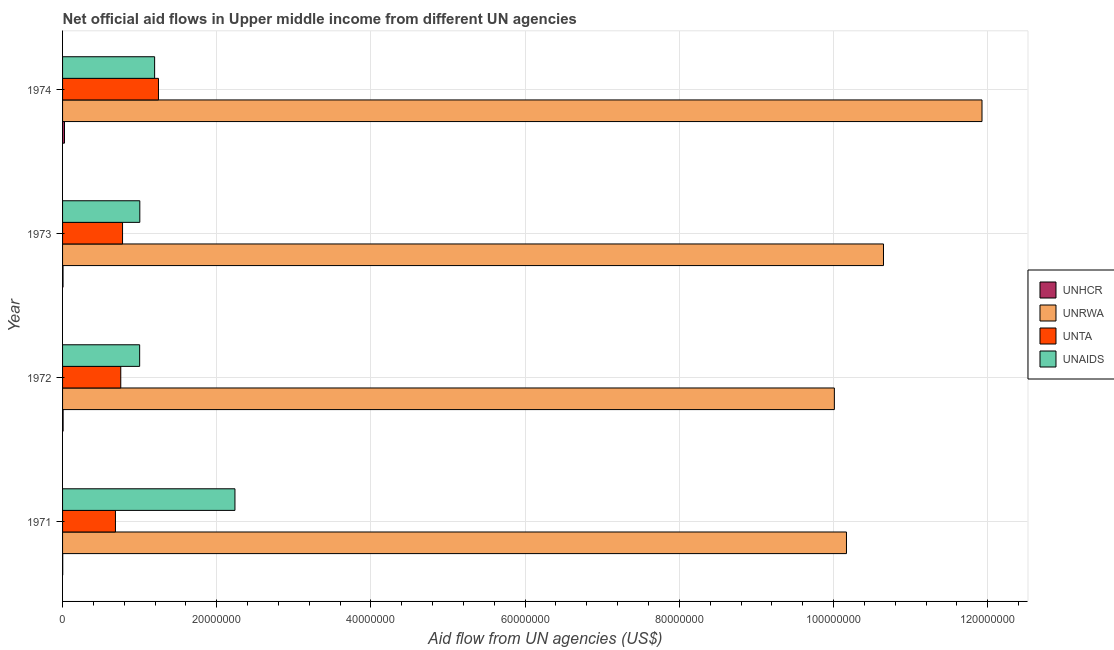How many different coloured bars are there?
Keep it short and to the point. 4. How many groups of bars are there?
Offer a terse response. 4. Are the number of bars per tick equal to the number of legend labels?
Provide a succinct answer. Yes. Are the number of bars on each tick of the Y-axis equal?
Your response must be concise. Yes. How many bars are there on the 4th tick from the bottom?
Offer a very short reply. 4. In how many cases, is the number of bars for a given year not equal to the number of legend labels?
Your response must be concise. 0. What is the amount of aid given by unhcr in 1973?
Offer a very short reply. 6.00e+04. Across all years, what is the maximum amount of aid given by unhcr?
Provide a succinct answer. 2.50e+05. Across all years, what is the minimum amount of aid given by unrwa?
Your answer should be compact. 1.00e+08. In which year was the amount of aid given by unaids maximum?
Provide a short and direct response. 1971. What is the total amount of aid given by unta in the graph?
Keep it short and to the point. 3.46e+07. What is the difference between the amount of aid given by unrwa in 1972 and that in 1974?
Keep it short and to the point. -1.92e+07. What is the difference between the amount of aid given by unhcr in 1972 and the amount of aid given by unaids in 1973?
Offer a very short reply. -9.95e+06. What is the average amount of aid given by unrwa per year?
Your response must be concise. 1.07e+08. In the year 1974, what is the difference between the amount of aid given by unrwa and amount of aid given by unaids?
Your answer should be very brief. 1.07e+08. In how many years, is the amount of aid given by unhcr greater than 116000000 US$?
Provide a succinct answer. 0. What is the ratio of the amount of aid given by unrwa in 1971 to that in 1972?
Offer a very short reply. 1.02. Is the amount of aid given by unaids in 1971 less than that in 1972?
Keep it short and to the point. No. What is the difference between the highest and the second highest amount of aid given by unta?
Keep it short and to the point. 4.66e+06. What is the difference between the highest and the lowest amount of aid given by unrwa?
Your response must be concise. 1.92e+07. Is the sum of the amount of aid given by unrwa in 1972 and 1973 greater than the maximum amount of aid given by unta across all years?
Your response must be concise. Yes. What does the 2nd bar from the top in 1972 represents?
Offer a very short reply. UNTA. What does the 3rd bar from the bottom in 1971 represents?
Keep it short and to the point. UNTA. Are the values on the major ticks of X-axis written in scientific E-notation?
Offer a terse response. No. Does the graph contain any zero values?
Provide a short and direct response. No. Where does the legend appear in the graph?
Make the answer very short. Center right. How are the legend labels stacked?
Your answer should be compact. Vertical. What is the title of the graph?
Provide a short and direct response. Net official aid flows in Upper middle income from different UN agencies. What is the label or title of the X-axis?
Your answer should be very brief. Aid flow from UN agencies (US$). What is the Aid flow from UN agencies (US$) of UNRWA in 1971?
Offer a very short reply. 1.02e+08. What is the Aid flow from UN agencies (US$) in UNTA in 1971?
Give a very brief answer. 6.86e+06. What is the Aid flow from UN agencies (US$) in UNAIDS in 1971?
Keep it short and to the point. 2.24e+07. What is the Aid flow from UN agencies (US$) in UNRWA in 1972?
Offer a very short reply. 1.00e+08. What is the Aid flow from UN agencies (US$) of UNTA in 1972?
Ensure brevity in your answer.  7.55e+06. What is the Aid flow from UN agencies (US$) in UNRWA in 1973?
Your answer should be very brief. 1.06e+08. What is the Aid flow from UN agencies (US$) of UNTA in 1973?
Give a very brief answer. 7.78e+06. What is the Aid flow from UN agencies (US$) in UNAIDS in 1973?
Ensure brevity in your answer.  1.00e+07. What is the Aid flow from UN agencies (US$) in UNRWA in 1974?
Offer a very short reply. 1.19e+08. What is the Aid flow from UN agencies (US$) in UNTA in 1974?
Offer a terse response. 1.24e+07. What is the Aid flow from UN agencies (US$) of UNAIDS in 1974?
Your answer should be very brief. 1.19e+07. Across all years, what is the maximum Aid flow from UN agencies (US$) in UNRWA?
Offer a terse response. 1.19e+08. Across all years, what is the maximum Aid flow from UN agencies (US$) in UNTA?
Ensure brevity in your answer.  1.24e+07. Across all years, what is the maximum Aid flow from UN agencies (US$) in UNAIDS?
Keep it short and to the point. 2.24e+07. Across all years, what is the minimum Aid flow from UN agencies (US$) in UNRWA?
Give a very brief answer. 1.00e+08. Across all years, what is the minimum Aid flow from UN agencies (US$) in UNTA?
Your answer should be compact. 6.86e+06. Across all years, what is the minimum Aid flow from UN agencies (US$) in UNAIDS?
Offer a very short reply. 1.00e+07. What is the total Aid flow from UN agencies (US$) of UNRWA in the graph?
Your answer should be compact. 4.28e+08. What is the total Aid flow from UN agencies (US$) in UNTA in the graph?
Your response must be concise. 3.46e+07. What is the total Aid flow from UN agencies (US$) in UNAIDS in the graph?
Your answer should be compact. 5.43e+07. What is the difference between the Aid flow from UN agencies (US$) in UNHCR in 1971 and that in 1972?
Offer a very short reply. -5.00e+04. What is the difference between the Aid flow from UN agencies (US$) in UNRWA in 1971 and that in 1972?
Keep it short and to the point. 1.57e+06. What is the difference between the Aid flow from UN agencies (US$) in UNTA in 1971 and that in 1972?
Offer a very short reply. -6.90e+05. What is the difference between the Aid flow from UN agencies (US$) of UNAIDS in 1971 and that in 1972?
Offer a terse response. 1.24e+07. What is the difference between the Aid flow from UN agencies (US$) in UNRWA in 1971 and that in 1973?
Offer a very short reply. -4.80e+06. What is the difference between the Aid flow from UN agencies (US$) in UNTA in 1971 and that in 1973?
Your answer should be very brief. -9.20e+05. What is the difference between the Aid flow from UN agencies (US$) of UNAIDS in 1971 and that in 1973?
Ensure brevity in your answer.  1.23e+07. What is the difference between the Aid flow from UN agencies (US$) in UNRWA in 1971 and that in 1974?
Offer a very short reply. -1.76e+07. What is the difference between the Aid flow from UN agencies (US$) of UNTA in 1971 and that in 1974?
Your response must be concise. -5.58e+06. What is the difference between the Aid flow from UN agencies (US$) in UNAIDS in 1971 and that in 1974?
Provide a succinct answer. 1.04e+07. What is the difference between the Aid flow from UN agencies (US$) in UNRWA in 1972 and that in 1973?
Your answer should be very brief. -6.37e+06. What is the difference between the Aid flow from UN agencies (US$) in UNAIDS in 1972 and that in 1973?
Your response must be concise. -2.00e+04. What is the difference between the Aid flow from UN agencies (US$) in UNHCR in 1972 and that in 1974?
Provide a short and direct response. -1.80e+05. What is the difference between the Aid flow from UN agencies (US$) of UNRWA in 1972 and that in 1974?
Give a very brief answer. -1.92e+07. What is the difference between the Aid flow from UN agencies (US$) in UNTA in 1972 and that in 1974?
Your answer should be very brief. -4.89e+06. What is the difference between the Aid flow from UN agencies (US$) of UNAIDS in 1972 and that in 1974?
Offer a very short reply. -1.94e+06. What is the difference between the Aid flow from UN agencies (US$) of UNRWA in 1973 and that in 1974?
Offer a very short reply. -1.28e+07. What is the difference between the Aid flow from UN agencies (US$) in UNTA in 1973 and that in 1974?
Give a very brief answer. -4.66e+06. What is the difference between the Aid flow from UN agencies (US$) of UNAIDS in 1973 and that in 1974?
Keep it short and to the point. -1.92e+06. What is the difference between the Aid flow from UN agencies (US$) in UNHCR in 1971 and the Aid flow from UN agencies (US$) in UNRWA in 1972?
Give a very brief answer. -1.00e+08. What is the difference between the Aid flow from UN agencies (US$) of UNHCR in 1971 and the Aid flow from UN agencies (US$) of UNTA in 1972?
Keep it short and to the point. -7.53e+06. What is the difference between the Aid flow from UN agencies (US$) in UNHCR in 1971 and the Aid flow from UN agencies (US$) in UNAIDS in 1972?
Make the answer very short. -9.98e+06. What is the difference between the Aid flow from UN agencies (US$) in UNRWA in 1971 and the Aid flow from UN agencies (US$) in UNTA in 1972?
Make the answer very short. 9.41e+07. What is the difference between the Aid flow from UN agencies (US$) in UNRWA in 1971 and the Aid flow from UN agencies (US$) in UNAIDS in 1972?
Offer a terse response. 9.17e+07. What is the difference between the Aid flow from UN agencies (US$) of UNTA in 1971 and the Aid flow from UN agencies (US$) of UNAIDS in 1972?
Offer a terse response. -3.14e+06. What is the difference between the Aid flow from UN agencies (US$) of UNHCR in 1971 and the Aid flow from UN agencies (US$) of UNRWA in 1973?
Offer a terse response. -1.06e+08. What is the difference between the Aid flow from UN agencies (US$) in UNHCR in 1971 and the Aid flow from UN agencies (US$) in UNTA in 1973?
Your answer should be very brief. -7.76e+06. What is the difference between the Aid flow from UN agencies (US$) in UNHCR in 1971 and the Aid flow from UN agencies (US$) in UNAIDS in 1973?
Your answer should be compact. -1.00e+07. What is the difference between the Aid flow from UN agencies (US$) in UNRWA in 1971 and the Aid flow from UN agencies (US$) in UNTA in 1973?
Your answer should be very brief. 9.39e+07. What is the difference between the Aid flow from UN agencies (US$) of UNRWA in 1971 and the Aid flow from UN agencies (US$) of UNAIDS in 1973?
Provide a short and direct response. 9.17e+07. What is the difference between the Aid flow from UN agencies (US$) in UNTA in 1971 and the Aid flow from UN agencies (US$) in UNAIDS in 1973?
Your response must be concise. -3.16e+06. What is the difference between the Aid flow from UN agencies (US$) of UNHCR in 1971 and the Aid flow from UN agencies (US$) of UNRWA in 1974?
Your answer should be very brief. -1.19e+08. What is the difference between the Aid flow from UN agencies (US$) of UNHCR in 1971 and the Aid flow from UN agencies (US$) of UNTA in 1974?
Your answer should be very brief. -1.24e+07. What is the difference between the Aid flow from UN agencies (US$) of UNHCR in 1971 and the Aid flow from UN agencies (US$) of UNAIDS in 1974?
Provide a short and direct response. -1.19e+07. What is the difference between the Aid flow from UN agencies (US$) in UNRWA in 1971 and the Aid flow from UN agencies (US$) in UNTA in 1974?
Provide a succinct answer. 8.92e+07. What is the difference between the Aid flow from UN agencies (US$) in UNRWA in 1971 and the Aid flow from UN agencies (US$) in UNAIDS in 1974?
Your answer should be very brief. 8.97e+07. What is the difference between the Aid flow from UN agencies (US$) in UNTA in 1971 and the Aid flow from UN agencies (US$) in UNAIDS in 1974?
Offer a very short reply. -5.08e+06. What is the difference between the Aid flow from UN agencies (US$) in UNHCR in 1972 and the Aid flow from UN agencies (US$) in UNRWA in 1973?
Provide a succinct answer. -1.06e+08. What is the difference between the Aid flow from UN agencies (US$) in UNHCR in 1972 and the Aid flow from UN agencies (US$) in UNTA in 1973?
Offer a terse response. -7.71e+06. What is the difference between the Aid flow from UN agencies (US$) of UNHCR in 1972 and the Aid flow from UN agencies (US$) of UNAIDS in 1973?
Offer a very short reply. -9.95e+06. What is the difference between the Aid flow from UN agencies (US$) of UNRWA in 1972 and the Aid flow from UN agencies (US$) of UNTA in 1973?
Provide a short and direct response. 9.23e+07. What is the difference between the Aid flow from UN agencies (US$) in UNRWA in 1972 and the Aid flow from UN agencies (US$) in UNAIDS in 1973?
Give a very brief answer. 9.01e+07. What is the difference between the Aid flow from UN agencies (US$) in UNTA in 1972 and the Aid flow from UN agencies (US$) in UNAIDS in 1973?
Offer a very short reply. -2.47e+06. What is the difference between the Aid flow from UN agencies (US$) in UNHCR in 1972 and the Aid flow from UN agencies (US$) in UNRWA in 1974?
Your answer should be compact. -1.19e+08. What is the difference between the Aid flow from UN agencies (US$) of UNHCR in 1972 and the Aid flow from UN agencies (US$) of UNTA in 1974?
Provide a short and direct response. -1.24e+07. What is the difference between the Aid flow from UN agencies (US$) of UNHCR in 1972 and the Aid flow from UN agencies (US$) of UNAIDS in 1974?
Your response must be concise. -1.19e+07. What is the difference between the Aid flow from UN agencies (US$) of UNRWA in 1972 and the Aid flow from UN agencies (US$) of UNTA in 1974?
Your answer should be compact. 8.77e+07. What is the difference between the Aid flow from UN agencies (US$) in UNRWA in 1972 and the Aid flow from UN agencies (US$) in UNAIDS in 1974?
Keep it short and to the point. 8.82e+07. What is the difference between the Aid flow from UN agencies (US$) in UNTA in 1972 and the Aid flow from UN agencies (US$) in UNAIDS in 1974?
Give a very brief answer. -4.39e+06. What is the difference between the Aid flow from UN agencies (US$) in UNHCR in 1973 and the Aid flow from UN agencies (US$) in UNRWA in 1974?
Offer a terse response. -1.19e+08. What is the difference between the Aid flow from UN agencies (US$) in UNHCR in 1973 and the Aid flow from UN agencies (US$) in UNTA in 1974?
Provide a short and direct response. -1.24e+07. What is the difference between the Aid flow from UN agencies (US$) of UNHCR in 1973 and the Aid flow from UN agencies (US$) of UNAIDS in 1974?
Offer a terse response. -1.19e+07. What is the difference between the Aid flow from UN agencies (US$) in UNRWA in 1973 and the Aid flow from UN agencies (US$) in UNTA in 1974?
Your answer should be very brief. 9.40e+07. What is the difference between the Aid flow from UN agencies (US$) in UNRWA in 1973 and the Aid flow from UN agencies (US$) in UNAIDS in 1974?
Your answer should be very brief. 9.45e+07. What is the difference between the Aid flow from UN agencies (US$) of UNTA in 1973 and the Aid flow from UN agencies (US$) of UNAIDS in 1974?
Provide a short and direct response. -4.16e+06. What is the average Aid flow from UN agencies (US$) in UNRWA per year?
Make the answer very short. 1.07e+08. What is the average Aid flow from UN agencies (US$) in UNTA per year?
Give a very brief answer. 8.66e+06. What is the average Aid flow from UN agencies (US$) of UNAIDS per year?
Offer a very short reply. 1.36e+07. In the year 1971, what is the difference between the Aid flow from UN agencies (US$) in UNHCR and Aid flow from UN agencies (US$) in UNRWA?
Ensure brevity in your answer.  -1.02e+08. In the year 1971, what is the difference between the Aid flow from UN agencies (US$) of UNHCR and Aid flow from UN agencies (US$) of UNTA?
Ensure brevity in your answer.  -6.84e+06. In the year 1971, what is the difference between the Aid flow from UN agencies (US$) of UNHCR and Aid flow from UN agencies (US$) of UNAIDS?
Give a very brief answer. -2.23e+07. In the year 1971, what is the difference between the Aid flow from UN agencies (US$) of UNRWA and Aid flow from UN agencies (US$) of UNTA?
Provide a short and direct response. 9.48e+07. In the year 1971, what is the difference between the Aid flow from UN agencies (US$) of UNRWA and Aid flow from UN agencies (US$) of UNAIDS?
Provide a short and direct response. 7.93e+07. In the year 1971, what is the difference between the Aid flow from UN agencies (US$) of UNTA and Aid flow from UN agencies (US$) of UNAIDS?
Ensure brevity in your answer.  -1.55e+07. In the year 1972, what is the difference between the Aid flow from UN agencies (US$) in UNHCR and Aid flow from UN agencies (US$) in UNRWA?
Offer a terse response. -1.00e+08. In the year 1972, what is the difference between the Aid flow from UN agencies (US$) in UNHCR and Aid flow from UN agencies (US$) in UNTA?
Ensure brevity in your answer.  -7.48e+06. In the year 1972, what is the difference between the Aid flow from UN agencies (US$) in UNHCR and Aid flow from UN agencies (US$) in UNAIDS?
Your answer should be very brief. -9.93e+06. In the year 1972, what is the difference between the Aid flow from UN agencies (US$) in UNRWA and Aid flow from UN agencies (US$) in UNTA?
Offer a terse response. 9.26e+07. In the year 1972, what is the difference between the Aid flow from UN agencies (US$) of UNRWA and Aid flow from UN agencies (US$) of UNAIDS?
Ensure brevity in your answer.  9.01e+07. In the year 1972, what is the difference between the Aid flow from UN agencies (US$) of UNTA and Aid flow from UN agencies (US$) of UNAIDS?
Offer a terse response. -2.45e+06. In the year 1973, what is the difference between the Aid flow from UN agencies (US$) of UNHCR and Aid flow from UN agencies (US$) of UNRWA?
Provide a succinct answer. -1.06e+08. In the year 1973, what is the difference between the Aid flow from UN agencies (US$) of UNHCR and Aid flow from UN agencies (US$) of UNTA?
Offer a very short reply. -7.72e+06. In the year 1973, what is the difference between the Aid flow from UN agencies (US$) of UNHCR and Aid flow from UN agencies (US$) of UNAIDS?
Your answer should be compact. -9.96e+06. In the year 1973, what is the difference between the Aid flow from UN agencies (US$) in UNRWA and Aid flow from UN agencies (US$) in UNTA?
Keep it short and to the point. 9.87e+07. In the year 1973, what is the difference between the Aid flow from UN agencies (US$) in UNRWA and Aid flow from UN agencies (US$) in UNAIDS?
Offer a terse response. 9.65e+07. In the year 1973, what is the difference between the Aid flow from UN agencies (US$) in UNTA and Aid flow from UN agencies (US$) in UNAIDS?
Ensure brevity in your answer.  -2.24e+06. In the year 1974, what is the difference between the Aid flow from UN agencies (US$) of UNHCR and Aid flow from UN agencies (US$) of UNRWA?
Ensure brevity in your answer.  -1.19e+08. In the year 1974, what is the difference between the Aid flow from UN agencies (US$) in UNHCR and Aid flow from UN agencies (US$) in UNTA?
Ensure brevity in your answer.  -1.22e+07. In the year 1974, what is the difference between the Aid flow from UN agencies (US$) in UNHCR and Aid flow from UN agencies (US$) in UNAIDS?
Your answer should be compact. -1.17e+07. In the year 1974, what is the difference between the Aid flow from UN agencies (US$) in UNRWA and Aid flow from UN agencies (US$) in UNTA?
Provide a short and direct response. 1.07e+08. In the year 1974, what is the difference between the Aid flow from UN agencies (US$) in UNRWA and Aid flow from UN agencies (US$) in UNAIDS?
Offer a very short reply. 1.07e+08. What is the ratio of the Aid flow from UN agencies (US$) of UNHCR in 1971 to that in 1972?
Give a very brief answer. 0.29. What is the ratio of the Aid flow from UN agencies (US$) in UNRWA in 1971 to that in 1972?
Your response must be concise. 1.02. What is the ratio of the Aid flow from UN agencies (US$) in UNTA in 1971 to that in 1972?
Offer a very short reply. 0.91. What is the ratio of the Aid flow from UN agencies (US$) of UNAIDS in 1971 to that in 1972?
Offer a very short reply. 2.24. What is the ratio of the Aid flow from UN agencies (US$) in UNHCR in 1971 to that in 1973?
Make the answer very short. 0.33. What is the ratio of the Aid flow from UN agencies (US$) in UNRWA in 1971 to that in 1973?
Ensure brevity in your answer.  0.95. What is the ratio of the Aid flow from UN agencies (US$) of UNTA in 1971 to that in 1973?
Provide a short and direct response. 0.88. What is the ratio of the Aid flow from UN agencies (US$) of UNAIDS in 1971 to that in 1973?
Your answer should be very brief. 2.23. What is the ratio of the Aid flow from UN agencies (US$) in UNRWA in 1971 to that in 1974?
Your answer should be compact. 0.85. What is the ratio of the Aid flow from UN agencies (US$) of UNTA in 1971 to that in 1974?
Offer a very short reply. 0.55. What is the ratio of the Aid flow from UN agencies (US$) of UNAIDS in 1971 to that in 1974?
Your answer should be compact. 1.87. What is the ratio of the Aid flow from UN agencies (US$) of UNRWA in 1972 to that in 1973?
Ensure brevity in your answer.  0.94. What is the ratio of the Aid flow from UN agencies (US$) in UNTA in 1972 to that in 1973?
Give a very brief answer. 0.97. What is the ratio of the Aid flow from UN agencies (US$) of UNHCR in 1972 to that in 1974?
Offer a terse response. 0.28. What is the ratio of the Aid flow from UN agencies (US$) in UNRWA in 1972 to that in 1974?
Provide a short and direct response. 0.84. What is the ratio of the Aid flow from UN agencies (US$) of UNTA in 1972 to that in 1974?
Your answer should be compact. 0.61. What is the ratio of the Aid flow from UN agencies (US$) in UNAIDS in 1972 to that in 1974?
Give a very brief answer. 0.84. What is the ratio of the Aid flow from UN agencies (US$) in UNHCR in 1973 to that in 1974?
Give a very brief answer. 0.24. What is the ratio of the Aid flow from UN agencies (US$) in UNRWA in 1973 to that in 1974?
Your answer should be very brief. 0.89. What is the ratio of the Aid flow from UN agencies (US$) of UNTA in 1973 to that in 1974?
Offer a very short reply. 0.63. What is the ratio of the Aid flow from UN agencies (US$) of UNAIDS in 1973 to that in 1974?
Provide a succinct answer. 0.84. What is the difference between the highest and the second highest Aid flow from UN agencies (US$) of UNHCR?
Offer a terse response. 1.80e+05. What is the difference between the highest and the second highest Aid flow from UN agencies (US$) in UNRWA?
Offer a terse response. 1.28e+07. What is the difference between the highest and the second highest Aid flow from UN agencies (US$) of UNTA?
Give a very brief answer. 4.66e+06. What is the difference between the highest and the second highest Aid flow from UN agencies (US$) of UNAIDS?
Keep it short and to the point. 1.04e+07. What is the difference between the highest and the lowest Aid flow from UN agencies (US$) of UNHCR?
Offer a very short reply. 2.30e+05. What is the difference between the highest and the lowest Aid flow from UN agencies (US$) of UNRWA?
Provide a short and direct response. 1.92e+07. What is the difference between the highest and the lowest Aid flow from UN agencies (US$) of UNTA?
Provide a succinct answer. 5.58e+06. What is the difference between the highest and the lowest Aid flow from UN agencies (US$) in UNAIDS?
Give a very brief answer. 1.24e+07. 